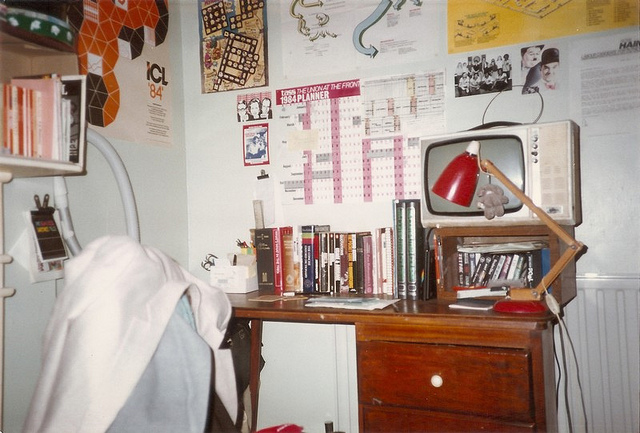Please extract the text content from this image. ICL 84 1984 THE i HA FROM PLANNER 